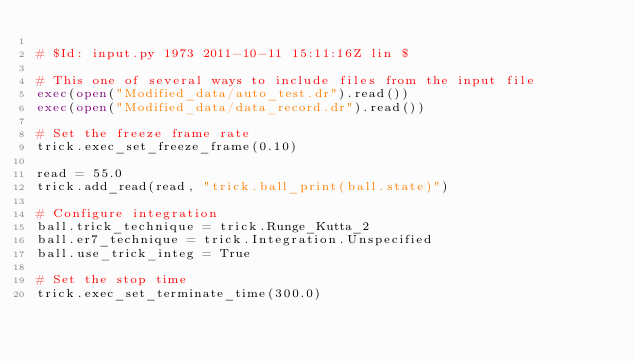Convert code to text. <code><loc_0><loc_0><loc_500><loc_500><_Python_>
# $Id: input.py 1973 2011-10-11 15:11:16Z lin $

# This one of several ways to include files from the input file
exec(open("Modified_data/auto_test.dr").read())
exec(open("Modified_data/data_record.dr").read())

# Set the freeze frame rate
trick.exec_set_freeze_frame(0.10)

read = 55.0 
trick.add_read(read, "trick.ball_print(ball.state)") 

# Configure integration
ball.trick_technique = trick.Runge_Kutta_2
ball.er7_technique = trick.Integration.Unspecified
ball.use_trick_integ = True

# Set the stop time 
trick.exec_set_terminate_time(300.0)

</code> 